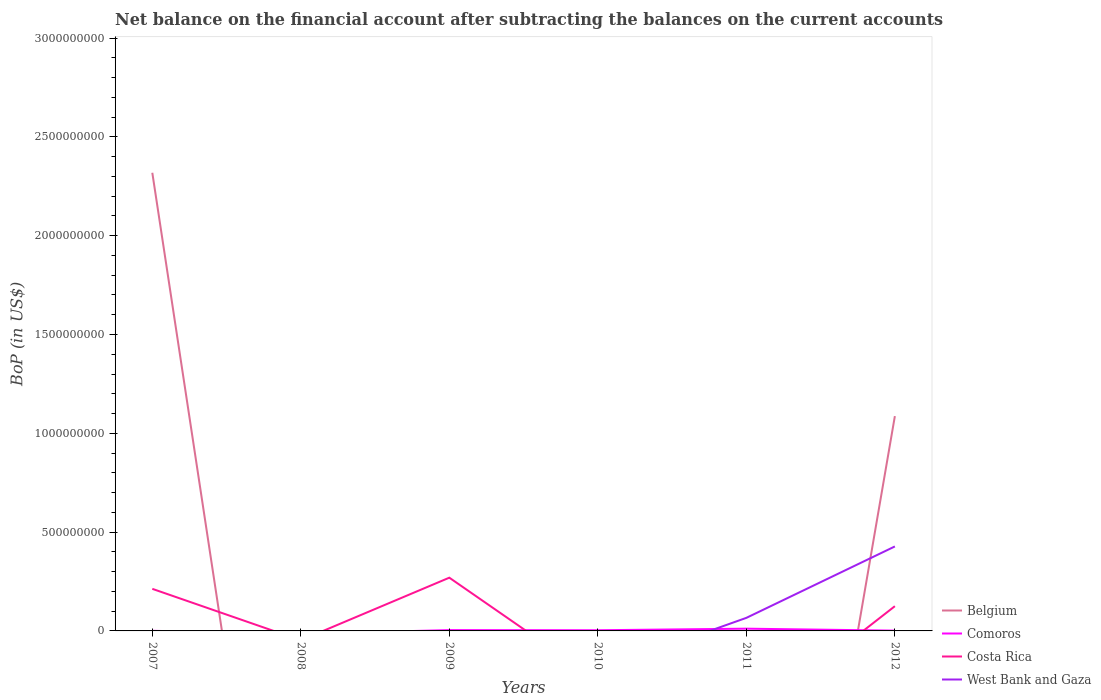Does the line corresponding to West Bank and Gaza intersect with the line corresponding to Costa Rica?
Keep it short and to the point. Yes. Across all years, what is the maximum Balance of Payments in Belgium?
Your response must be concise. 0. What is the total Balance of Payments in Comoros in the graph?
Ensure brevity in your answer.  2.69e+06. What is the difference between the highest and the second highest Balance of Payments in Belgium?
Offer a very short reply. 2.32e+09. How many lines are there?
Provide a succinct answer. 4. How many years are there in the graph?
Provide a succinct answer. 6. Are the values on the major ticks of Y-axis written in scientific E-notation?
Make the answer very short. No. Does the graph contain grids?
Your answer should be very brief. No. Where does the legend appear in the graph?
Ensure brevity in your answer.  Bottom right. How many legend labels are there?
Keep it short and to the point. 4. How are the legend labels stacked?
Your answer should be very brief. Vertical. What is the title of the graph?
Provide a succinct answer. Net balance on the financial account after subtracting the balances on the current accounts. Does "Vietnam" appear as one of the legend labels in the graph?
Ensure brevity in your answer.  No. What is the label or title of the Y-axis?
Make the answer very short. BoP (in US$). What is the BoP (in US$) of Belgium in 2007?
Make the answer very short. 2.32e+09. What is the BoP (in US$) in Comoros in 2007?
Your answer should be compact. 5.59e+05. What is the BoP (in US$) of Costa Rica in 2007?
Provide a succinct answer. 2.13e+08. What is the BoP (in US$) in Comoros in 2008?
Give a very brief answer. 0. What is the BoP (in US$) in Costa Rica in 2008?
Your response must be concise. 0. What is the BoP (in US$) of Belgium in 2009?
Offer a very short reply. 0. What is the BoP (in US$) in Comoros in 2009?
Make the answer very short. 4.08e+06. What is the BoP (in US$) in Costa Rica in 2009?
Ensure brevity in your answer.  2.69e+08. What is the BoP (in US$) in West Bank and Gaza in 2009?
Give a very brief answer. 0. What is the BoP (in US$) of Comoros in 2010?
Provide a succinct answer. 3.42e+06. What is the BoP (in US$) of Costa Rica in 2010?
Keep it short and to the point. 0. What is the BoP (in US$) in West Bank and Gaza in 2010?
Ensure brevity in your answer.  0. What is the BoP (in US$) in Comoros in 2011?
Provide a short and direct response. 1.13e+07. What is the BoP (in US$) in Costa Rica in 2011?
Offer a terse response. 0. What is the BoP (in US$) in West Bank and Gaza in 2011?
Keep it short and to the point. 6.61e+07. What is the BoP (in US$) in Belgium in 2012?
Your answer should be compact. 1.09e+09. What is the BoP (in US$) of Comoros in 2012?
Make the answer very short. 1.39e+06. What is the BoP (in US$) in Costa Rica in 2012?
Ensure brevity in your answer.  1.25e+08. What is the BoP (in US$) in West Bank and Gaza in 2012?
Keep it short and to the point. 4.28e+08. Across all years, what is the maximum BoP (in US$) in Belgium?
Provide a succinct answer. 2.32e+09. Across all years, what is the maximum BoP (in US$) in Comoros?
Provide a short and direct response. 1.13e+07. Across all years, what is the maximum BoP (in US$) of Costa Rica?
Your response must be concise. 2.69e+08. Across all years, what is the maximum BoP (in US$) of West Bank and Gaza?
Your response must be concise. 4.28e+08. Across all years, what is the minimum BoP (in US$) of Belgium?
Offer a terse response. 0. Across all years, what is the minimum BoP (in US$) in Costa Rica?
Your response must be concise. 0. Across all years, what is the minimum BoP (in US$) of West Bank and Gaza?
Offer a very short reply. 0. What is the total BoP (in US$) in Belgium in the graph?
Make the answer very short. 3.41e+09. What is the total BoP (in US$) of Comoros in the graph?
Your answer should be compact. 2.08e+07. What is the total BoP (in US$) of Costa Rica in the graph?
Offer a terse response. 6.08e+08. What is the total BoP (in US$) in West Bank and Gaza in the graph?
Your answer should be very brief. 4.94e+08. What is the difference between the BoP (in US$) in Comoros in 2007 and that in 2009?
Your response must be concise. -3.52e+06. What is the difference between the BoP (in US$) of Costa Rica in 2007 and that in 2009?
Your answer should be compact. -5.64e+07. What is the difference between the BoP (in US$) of Comoros in 2007 and that in 2010?
Offer a terse response. -2.86e+06. What is the difference between the BoP (in US$) in Comoros in 2007 and that in 2011?
Give a very brief answer. -1.08e+07. What is the difference between the BoP (in US$) of Belgium in 2007 and that in 2012?
Your answer should be very brief. 1.23e+09. What is the difference between the BoP (in US$) in Comoros in 2007 and that in 2012?
Give a very brief answer. -8.33e+05. What is the difference between the BoP (in US$) of Costa Rica in 2007 and that in 2012?
Make the answer very short. 8.78e+07. What is the difference between the BoP (in US$) of Comoros in 2009 and that in 2010?
Keep it short and to the point. 6.61e+05. What is the difference between the BoP (in US$) of Comoros in 2009 and that in 2011?
Your answer should be very brief. -7.27e+06. What is the difference between the BoP (in US$) of Comoros in 2009 and that in 2012?
Your answer should be very brief. 2.69e+06. What is the difference between the BoP (in US$) in Costa Rica in 2009 and that in 2012?
Ensure brevity in your answer.  1.44e+08. What is the difference between the BoP (in US$) in Comoros in 2010 and that in 2011?
Your answer should be compact. -7.93e+06. What is the difference between the BoP (in US$) in Comoros in 2010 and that in 2012?
Keep it short and to the point. 2.03e+06. What is the difference between the BoP (in US$) of Comoros in 2011 and that in 2012?
Provide a short and direct response. 9.95e+06. What is the difference between the BoP (in US$) in West Bank and Gaza in 2011 and that in 2012?
Provide a short and direct response. -3.61e+08. What is the difference between the BoP (in US$) in Belgium in 2007 and the BoP (in US$) in Comoros in 2009?
Provide a succinct answer. 2.31e+09. What is the difference between the BoP (in US$) in Belgium in 2007 and the BoP (in US$) in Costa Rica in 2009?
Provide a short and direct response. 2.05e+09. What is the difference between the BoP (in US$) in Comoros in 2007 and the BoP (in US$) in Costa Rica in 2009?
Offer a very short reply. -2.69e+08. What is the difference between the BoP (in US$) of Belgium in 2007 and the BoP (in US$) of Comoros in 2010?
Your answer should be compact. 2.32e+09. What is the difference between the BoP (in US$) in Belgium in 2007 and the BoP (in US$) in Comoros in 2011?
Keep it short and to the point. 2.31e+09. What is the difference between the BoP (in US$) of Belgium in 2007 and the BoP (in US$) of West Bank and Gaza in 2011?
Keep it short and to the point. 2.25e+09. What is the difference between the BoP (in US$) in Comoros in 2007 and the BoP (in US$) in West Bank and Gaza in 2011?
Give a very brief answer. -6.55e+07. What is the difference between the BoP (in US$) in Costa Rica in 2007 and the BoP (in US$) in West Bank and Gaza in 2011?
Offer a very short reply. 1.47e+08. What is the difference between the BoP (in US$) in Belgium in 2007 and the BoP (in US$) in Comoros in 2012?
Provide a succinct answer. 2.32e+09. What is the difference between the BoP (in US$) of Belgium in 2007 and the BoP (in US$) of Costa Rica in 2012?
Give a very brief answer. 2.19e+09. What is the difference between the BoP (in US$) in Belgium in 2007 and the BoP (in US$) in West Bank and Gaza in 2012?
Provide a short and direct response. 1.89e+09. What is the difference between the BoP (in US$) of Comoros in 2007 and the BoP (in US$) of Costa Rica in 2012?
Provide a short and direct response. -1.25e+08. What is the difference between the BoP (in US$) in Comoros in 2007 and the BoP (in US$) in West Bank and Gaza in 2012?
Offer a terse response. -4.27e+08. What is the difference between the BoP (in US$) of Costa Rica in 2007 and the BoP (in US$) of West Bank and Gaza in 2012?
Give a very brief answer. -2.15e+08. What is the difference between the BoP (in US$) in Comoros in 2009 and the BoP (in US$) in West Bank and Gaza in 2011?
Offer a terse response. -6.20e+07. What is the difference between the BoP (in US$) in Costa Rica in 2009 and the BoP (in US$) in West Bank and Gaza in 2011?
Provide a succinct answer. 2.03e+08. What is the difference between the BoP (in US$) in Comoros in 2009 and the BoP (in US$) in Costa Rica in 2012?
Keep it short and to the point. -1.21e+08. What is the difference between the BoP (in US$) of Comoros in 2009 and the BoP (in US$) of West Bank and Gaza in 2012?
Offer a very short reply. -4.23e+08. What is the difference between the BoP (in US$) in Costa Rica in 2009 and the BoP (in US$) in West Bank and Gaza in 2012?
Keep it short and to the point. -1.58e+08. What is the difference between the BoP (in US$) in Comoros in 2010 and the BoP (in US$) in West Bank and Gaza in 2011?
Your answer should be compact. -6.27e+07. What is the difference between the BoP (in US$) in Comoros in 2010 and the BoP (in US$) in Costa Rica in 2012?
Provide a succinct answer. -1.22e+08. What is the difference between the BoP (in US$) of Comoros in 2010 and the BoP (in US$) of West Bank and Gaza in 2012?
Give a very brief answer. -4.24e+08. What is the difference between the BoP (in US$) of Comoros in 2011 and the BoP (in US$) of Costa Rica in 2012?
Your answer should be very brief. -1.14e+08. What is the difference between the BoP (in US$) in Comoros in 2011 and the BoP (in US$) in West Bank and Gaza in 2012?
Keep it short and to the point. -4.16e+08. What is the average BoP (in US$) in Belgium per year?
Offer a terse response. 5.68e+08. What is the average BoP (in US$) of Comoros per year?
Offer a terse response. 3.47e+06. What is the average BoP (in US$) of Costa Rica per year?
Offer a terse response. 1.01e+08. What is the average BoP (in US$) in West Bank and Gaza per year?
Make the answer very short. 8.23e+07. In the year 2007, what is the difference between the BoP (in US$) in Belgium and BoP (in US$) in Comoros?
Provide a succinct answer. 2.32e+09. In the year 2007, what is the difference between the BoP (in US$) of Belgium and BoP (in US$) of Costa Rica?
Your response must be concise. 2.11e+09. In the year 2007, what is the difference between the BoP (in US$) in Comoros and BoP (in US$) in Costa Rica?
Your answer should be very brief. -2.12e+08. In the year 2009, what is the difference between the BoP (in US$) of Comoros and BoP (in US$) of Costa Rica?
Offer a very short reply. -2.65e+08. In the year 2011, what is the difference between the BoP (in US$) of Comoros and BoP (in US$) of West Bank and Gaza?
Provide a short and direct response. -5.48e+07. In the year 2012, what is the difference between the BoP (in US$) in Belgium and BoP (in US$) in Comoros?
Offer a very short reply. 1.09e+09. In the year 2012, what is the difference between the BoP (in US$) in Belgium and BoP (in US$) in Costa Rica?
Offer a terse response. 9.62e+08. In the year 2012, what is the difference between the BoP (in US$) in Belgium and BoP (in US$) in West Bank and Gaza?
Offer a very short reply. 6.60e+08. In the year 2012, what is the difference between the BoP (in US$) in Comoros and BoP (in US$) in Costa Rica?
Your answer should be compact. -1.24e+08. In the year 2012, what is the difference between the BoP (in US$) of Comoros and BoP (in US$) of West Bank and Gaza?
Make the answer very short. -4.26e+08. In the year 2012, what is the difference between the BoP (in US$) in Costa Rica and BoP (in US$) in West Bank and Gaza?
Make the answer very short. -3.02e+08. What is the ratio of the BoP (in US$) in Comoros in 2007 to that in 2009?
Your response must be concise. 0.14. What is the ratio of the BoP (in US$) in Costa Rica in 2007 to that in 2009?
Provide a short and direct response. 0.79. What is the ratio of the BoP (in US$) in Comoros in 2007 to that in 2010?
Your answer should be very brief. 0.16. What is the ratio of the BoP (in US$) of Comoros in 2007 to that in 2011?
Offer a very short reply. 0.05. What is the ratio of the BoP (in US$) of Belgium in 2007 to that in 2012?
Provide a short and direct response. 2.13. What is the ratio of the BoP (in US$) of Comoros in 2007 to that in 2012?
Provide a succinct answer. 0.4. What is the ratio of the BoP (in US$) of Costa Rica in 2007 to that in 2012?
Offer a terse response. 1.7. What is the ratio of the BoP (in US$) in Comoros in 2009 to that in 2010?
Your answer should be compact. 1.19. What is the ratio of the BoP (in US$) in Comoros in 2009 to that in 2011?
Your answer should be compact. 0.36. What is the ratio of the BoP (in US$) in Comoros in 2009 to that in 2012?
Make the answer very short. 2.93. What is the ratio of the BoP (in US$) in Costa Rica in 2009 to that in 2012?
Offer a terse response. 2.15. What is the ratio of the BoP (in US$) of Comoros in 2010 to that in 2011?
Your answer should be compact. 0.3. What is the ratio of the BoP (in US$) in Comoros in 2010 to that in 2012?
Provide a succinct answer. 2.46. What is the ratio of the BoP (in US$) in Comoros in 2011 to that in 2012?
Ensure brevity in your answer.  8.15. What is the ratio of the BoP (in US$) in West Bank and Gaza in 2011 to that in 2012?
Give a very brief answer. 0.15. What is the difference between the highest and the second highest BoP (in US$) of Comoros?
Your response must be concise. 7.27e+06. What is the difference between the highest and the second highest BoP (in US$) in Costa Rica?
Provide a short and direct response. 5.64e+07. What is the difference between the highest and the lowest BoP (in US$) in Belgium?
Make the answer very short. 2.32e+09. What is the difference between the highest and the lowest BoP (in US$) of Comoros?
Offer a very short reply. 1.13e+07. What is the difference between the highest and the lowest BoP (in US$) in Costa Rica?
Your answer should be compact. 2.69e+08. What is the difference between the highest and the lowest BoP (in US$) in West Bank and Gaza?
Keep it short and to the point. 4.28e+08. 